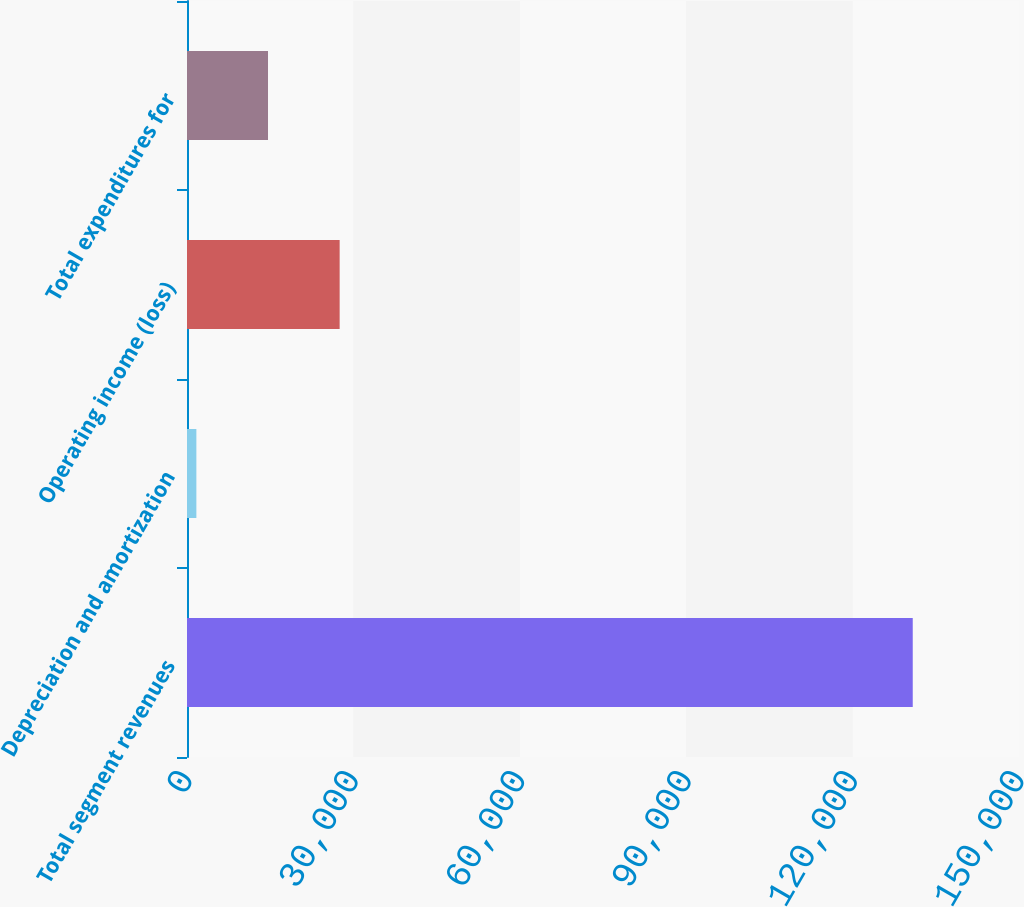Convert chart. <chart><loc_0><loc_0><loc_500><loc_500><bar_chart><fcel>Total segment revenues<fcel>Depreciation and amortization<fcel>Operating income (loss)<fcel>Total expenditures for<nl><fcel>130844<fcel>1690<fcel>27520.8<fcel>14605.4<nl></chart> 